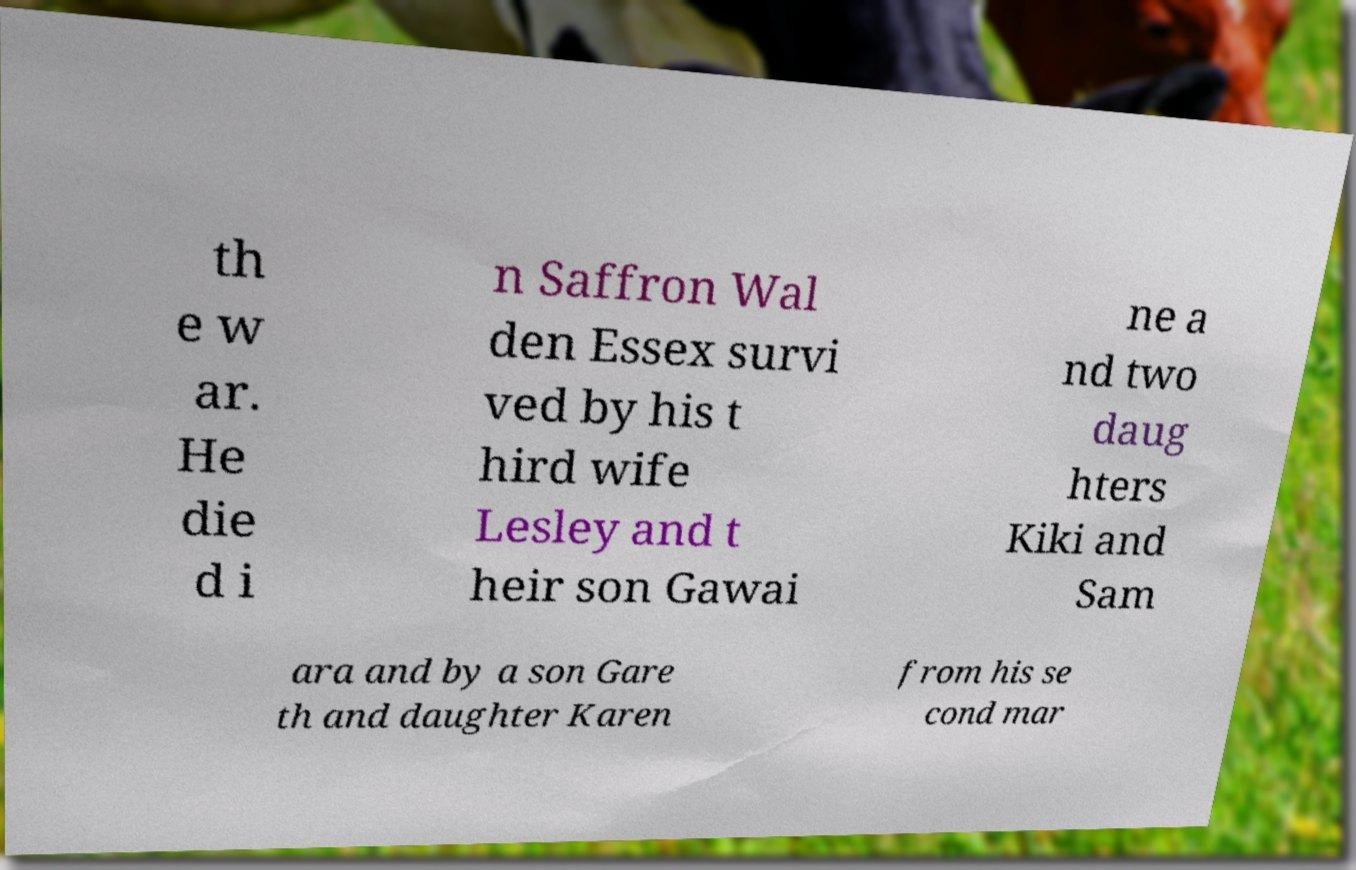Please read and relay the text visible in this image. What does it say? th e w ar. He die d i n Saffron Wal den Essex survi ved by his t hird wife Lesley and t heir son Gawai ne a nd two daug hters Kiki and Sam ara and by a son Gare th and daughter Karen from his se cond mar 